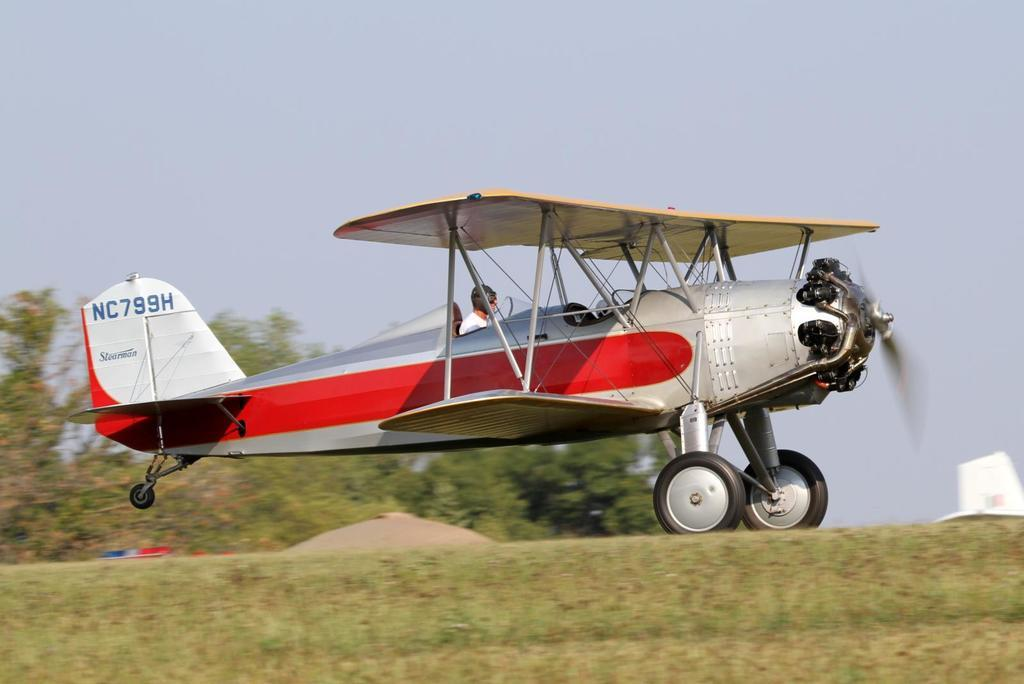<image>
Create a compact narrative representing the image presented. A propeller plane has the id of NC799H on the tail in blue. 